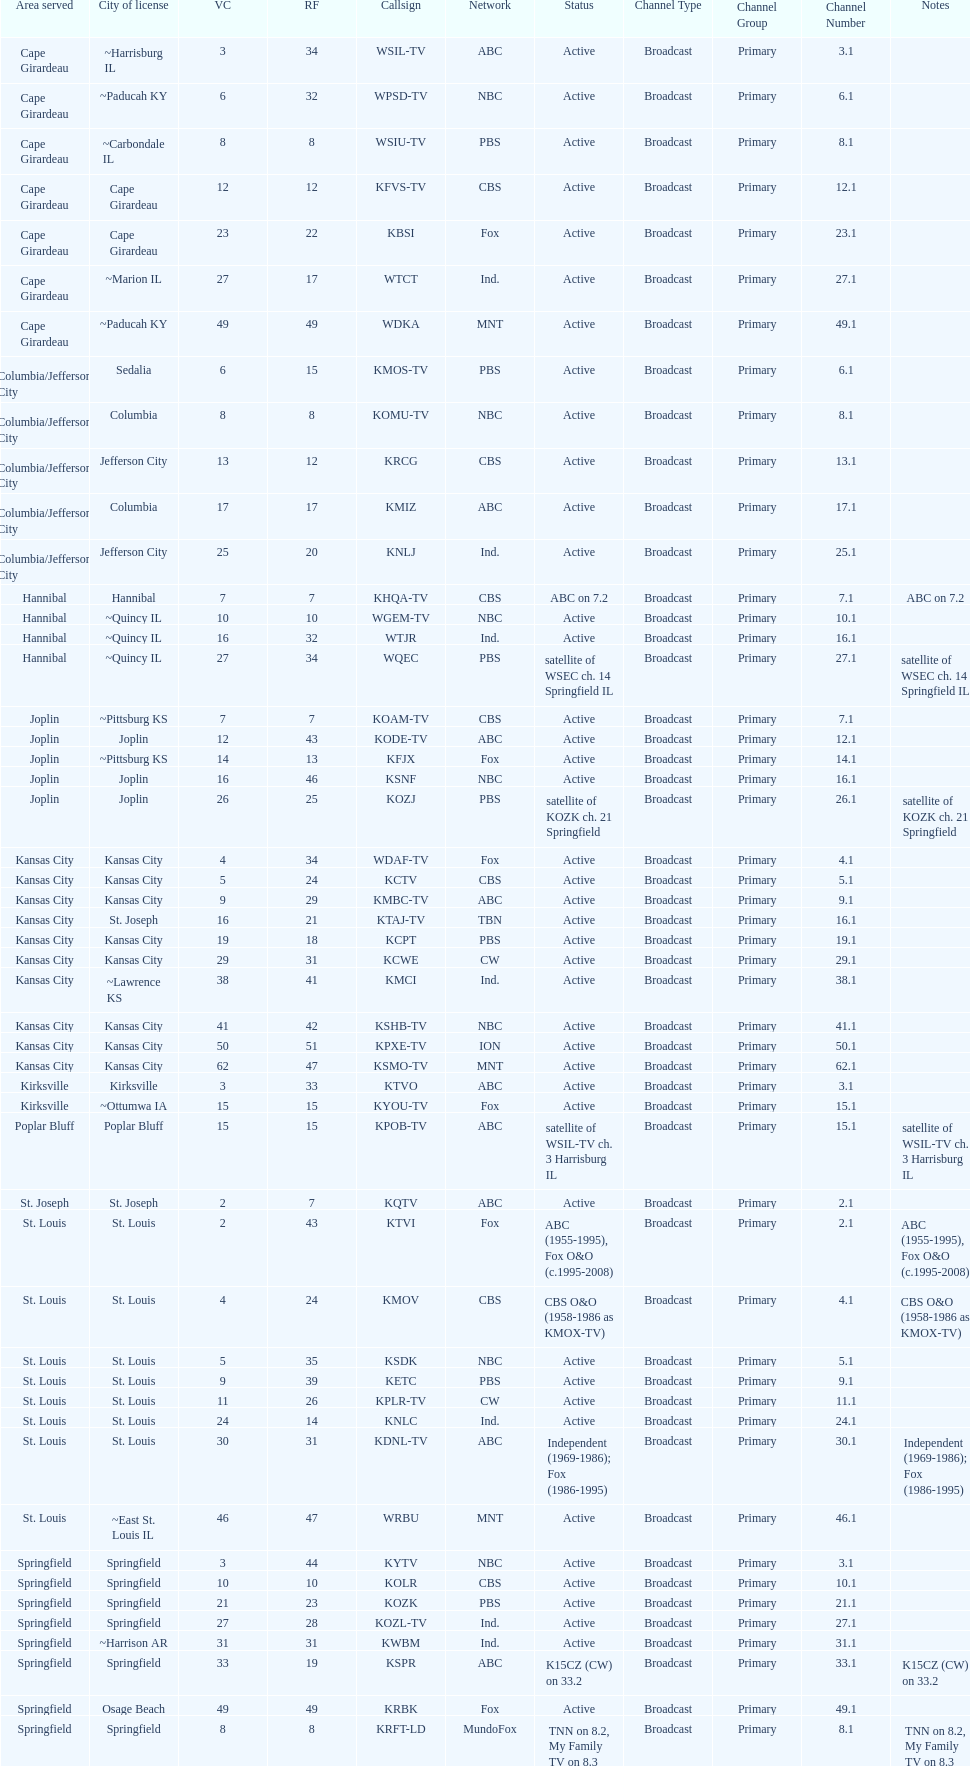What is the total number of cbs stations? 7. 